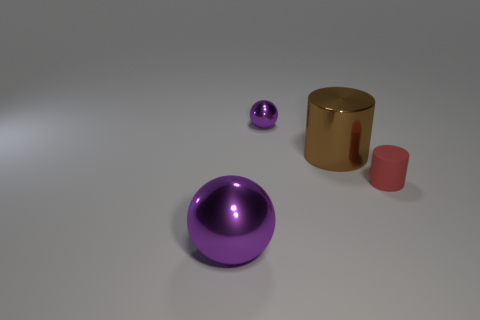Add 4 big purple spheres. How many objects exist? 8 Add 4 tiny green matte things. How many tiny green matte things exist? 4 Subtract 0 cyan cylinders. How many objects are left? 4 Subtract all large yellow metal cylinders. Subtract all tiny rubber things. How many objects are left? 3 Add 1 tiny purple metal things. How many tiny purple metal things are left? 2 